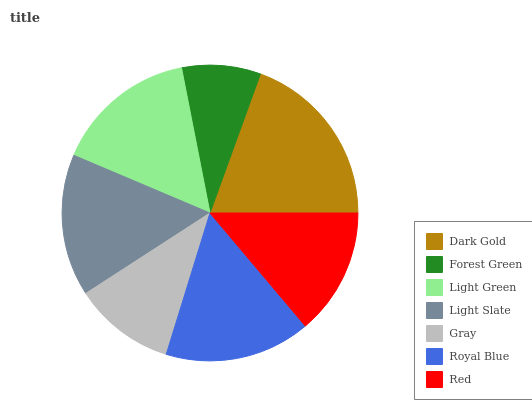Is Forest Green the minimum?
Answer yes or no. Yes. Is Dark Gold the maximum?
Answer yes or no. Yes. Is Light Green the minimum?
Answer yes or no. No. Is Light Green the maximum?
Answer yes or no. No. Is Light Green greater than Forest Green?
Answer yes or no. Yes. Is Forest Green less than Light Green?
Answer yes or no. Yes. Is Forest Green greater than Light Green?
Answer yes or no. No. Is Light Green less than Forest Green?
Answer yes or no. No. Is Light Slate the high median?
Answer yes or no. Yes. Is Light Slate the low median?
Answer yes or no. Yes. Is Gray the high median?
Answer yes or no. No. Is Gray the low median?
Answer yes or no. No. 